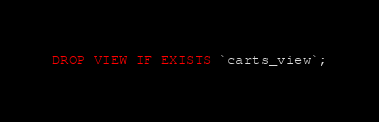Convert code to text. <code><loc_0><loc_0><loc_500><loc_500><_SQL_>DROP VIEW IF EXISTS `carts_view`;</code> 